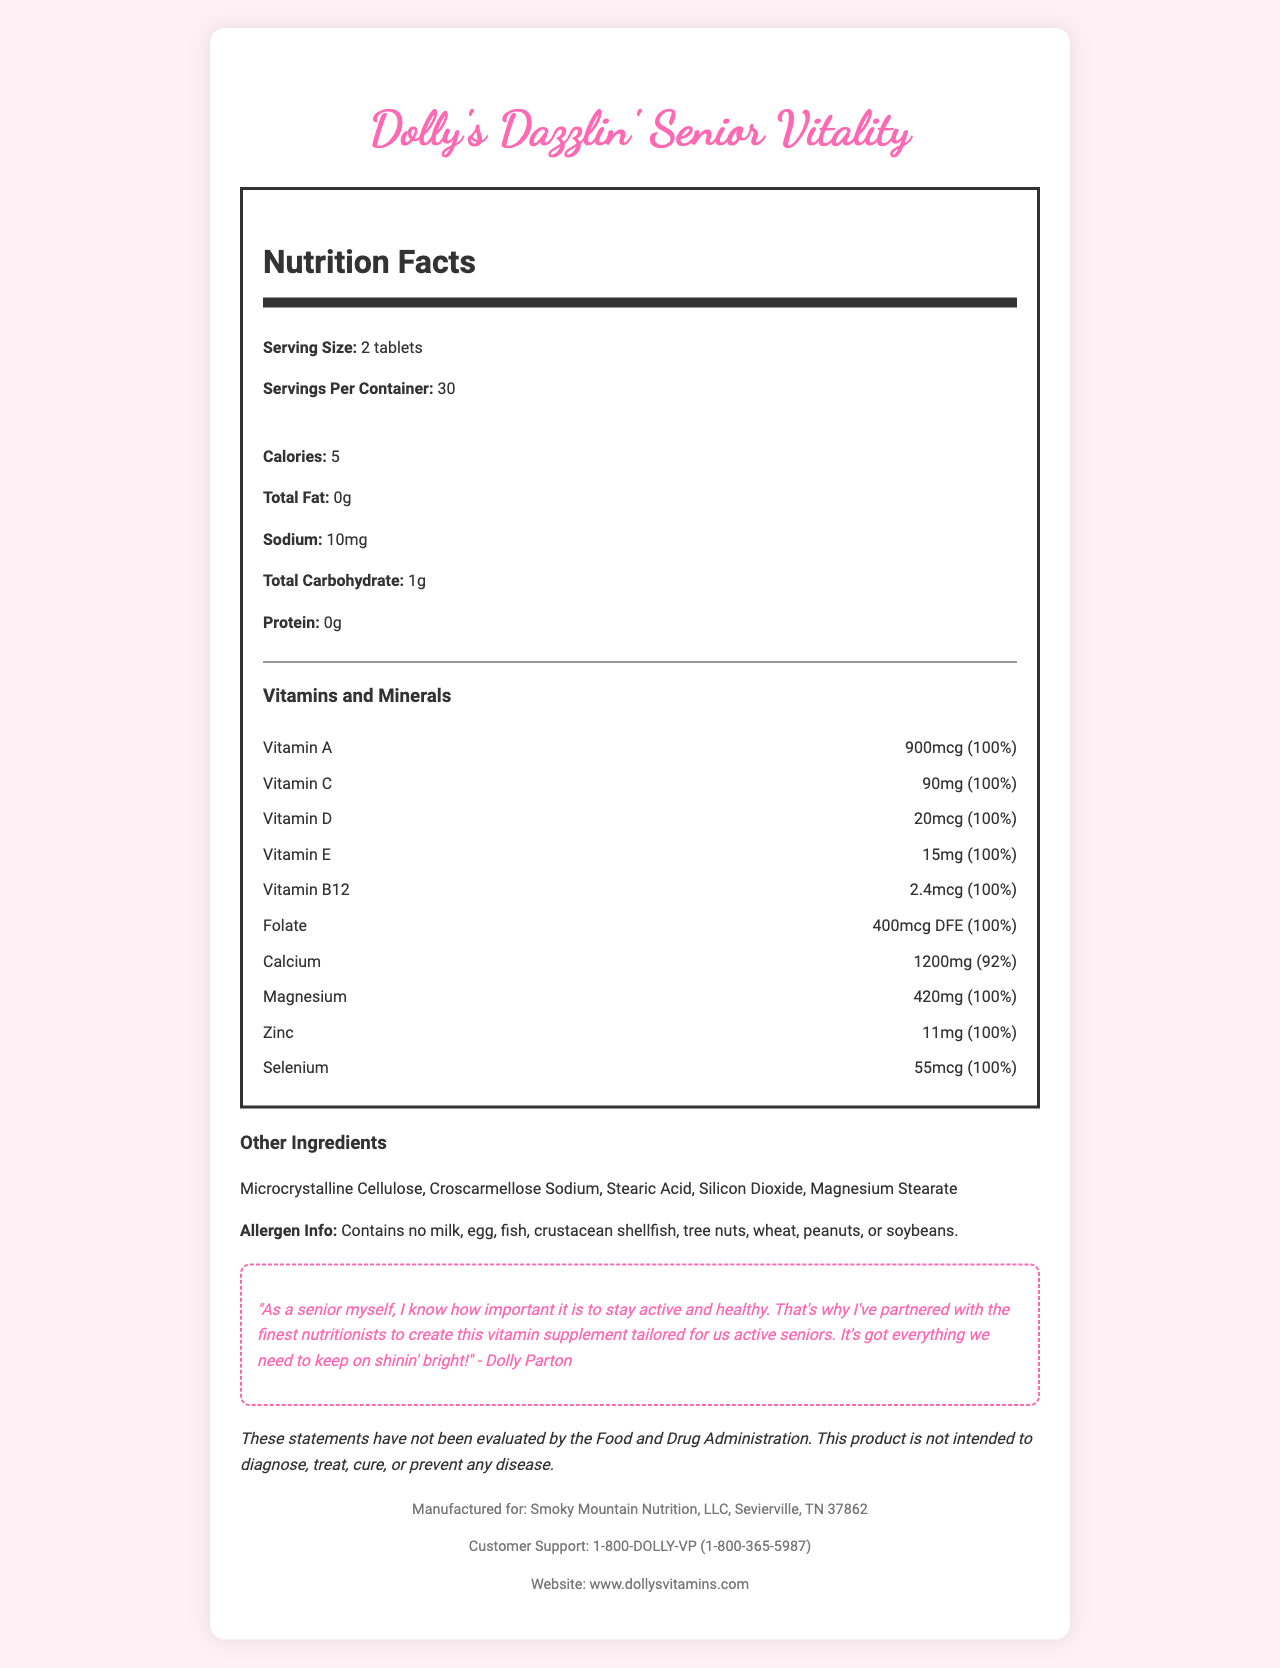what is the product name? The product name is clearly stated at the top of the document in the header section.
Answer: Dolly's Dazzlin' Senior Vitality what is the serving size? The serving size is specified in the Nutrition Facts section right below the header.
Answer: 2 tablets how many servings are there per container? The number of servings per container is listed in the Nutrition Facts section after the serving size.
Answer: 30 how many calories does each serving contain? The caloric content per serving is listed in the Nutrition Facts section under the calories subheading.
Answer: 5 how much sodium is in each serving? The sodium content per serving is listed in the Nutrition Facts section under sodium.
Answer: 10mg which vitamin has the highest daily value percentage? All these vitamins and minerals have a daily value of 100%.
Answer: Vitamin A, Vitamin C, Vitamin D, Vitamin E, Vitamin B12, Folate, Magnesium, Zinc, Selenium list three vitamins present in the supplement. These vitamins are listed in the Vitamins and Minerals section along with their respective amounts and daily values.
Answer: Vitamin A, Vitamin C, Vitamin D what other ingredients are included in the supplement? The other ingredients are listed under the section titled "Other Ingredients".
Answer: Microcrystalline Cellulose, Croscarmellose Sodium, Stearic Acid, Silicon Dioxide, Magnesium Stearate who endorses this vitamin supplement? There is an endorsement statement from Dolly Parton in the document.
Answer: Dolly Parton how much calcium does one serving provide? The amount of calcium per serving is specified in the Vitamins and Minerals section with an amount and daily value percentage.
Answer: 1200mg which statement is true according to the document? 
1. The supplement contains 10mg of Iron. 
2. The supplement contains 420mg of Magnesium. 
3. The supplement has a daily value of 50% for Zinc. 
4. The supplement includes allergenic ingredients. The document states that there is 420mg of Magnesium, while the other statements aren't supported by the given information.
Answer: 2 how much folate is in each serving? 
A. 300mcg DFE 
B. 400mcg DFE 
C. 500mcg DFE 
D. 600mcg DFE The document indicates that each serving contains 400mcg DFE of Folate.
Answer: B does the supplement contain any protein? The protein content per serving is listed as 0g in the Nutrition Facts section.
Answer: No is the supplement evaluated by the FDA for diagnosis or treatment? The disclaimer in the document clearly states that the product is not intended to diagnose, treat, cure, or prevent any disease and that these statements have not been evaluated by the FDA.
Answer: No summarize the main idea of the document. The document outlines the key aspects of the supplement including its nutritional profile, ingredients, endorsement, and additional information for consumers.
Answer: The document provides nutritional information for "Dolly's Dazzlin' Senior Vitality," a vitamin supplement for active seniors endorsed by Dolly Parton. It details the serving size, number of servings per container, calorie content, and various vitamins and minerals included. The document also lists other ingredients, allergen information, a disclaimer, endorsement from Dolly Parton, and contact details for the manufacturer. what are the manufacturing details for this supplement? The document does not explicitly list the manufacturing process details, it only provides the name and location of the manufacturer.
Answer: Cannot be determined 